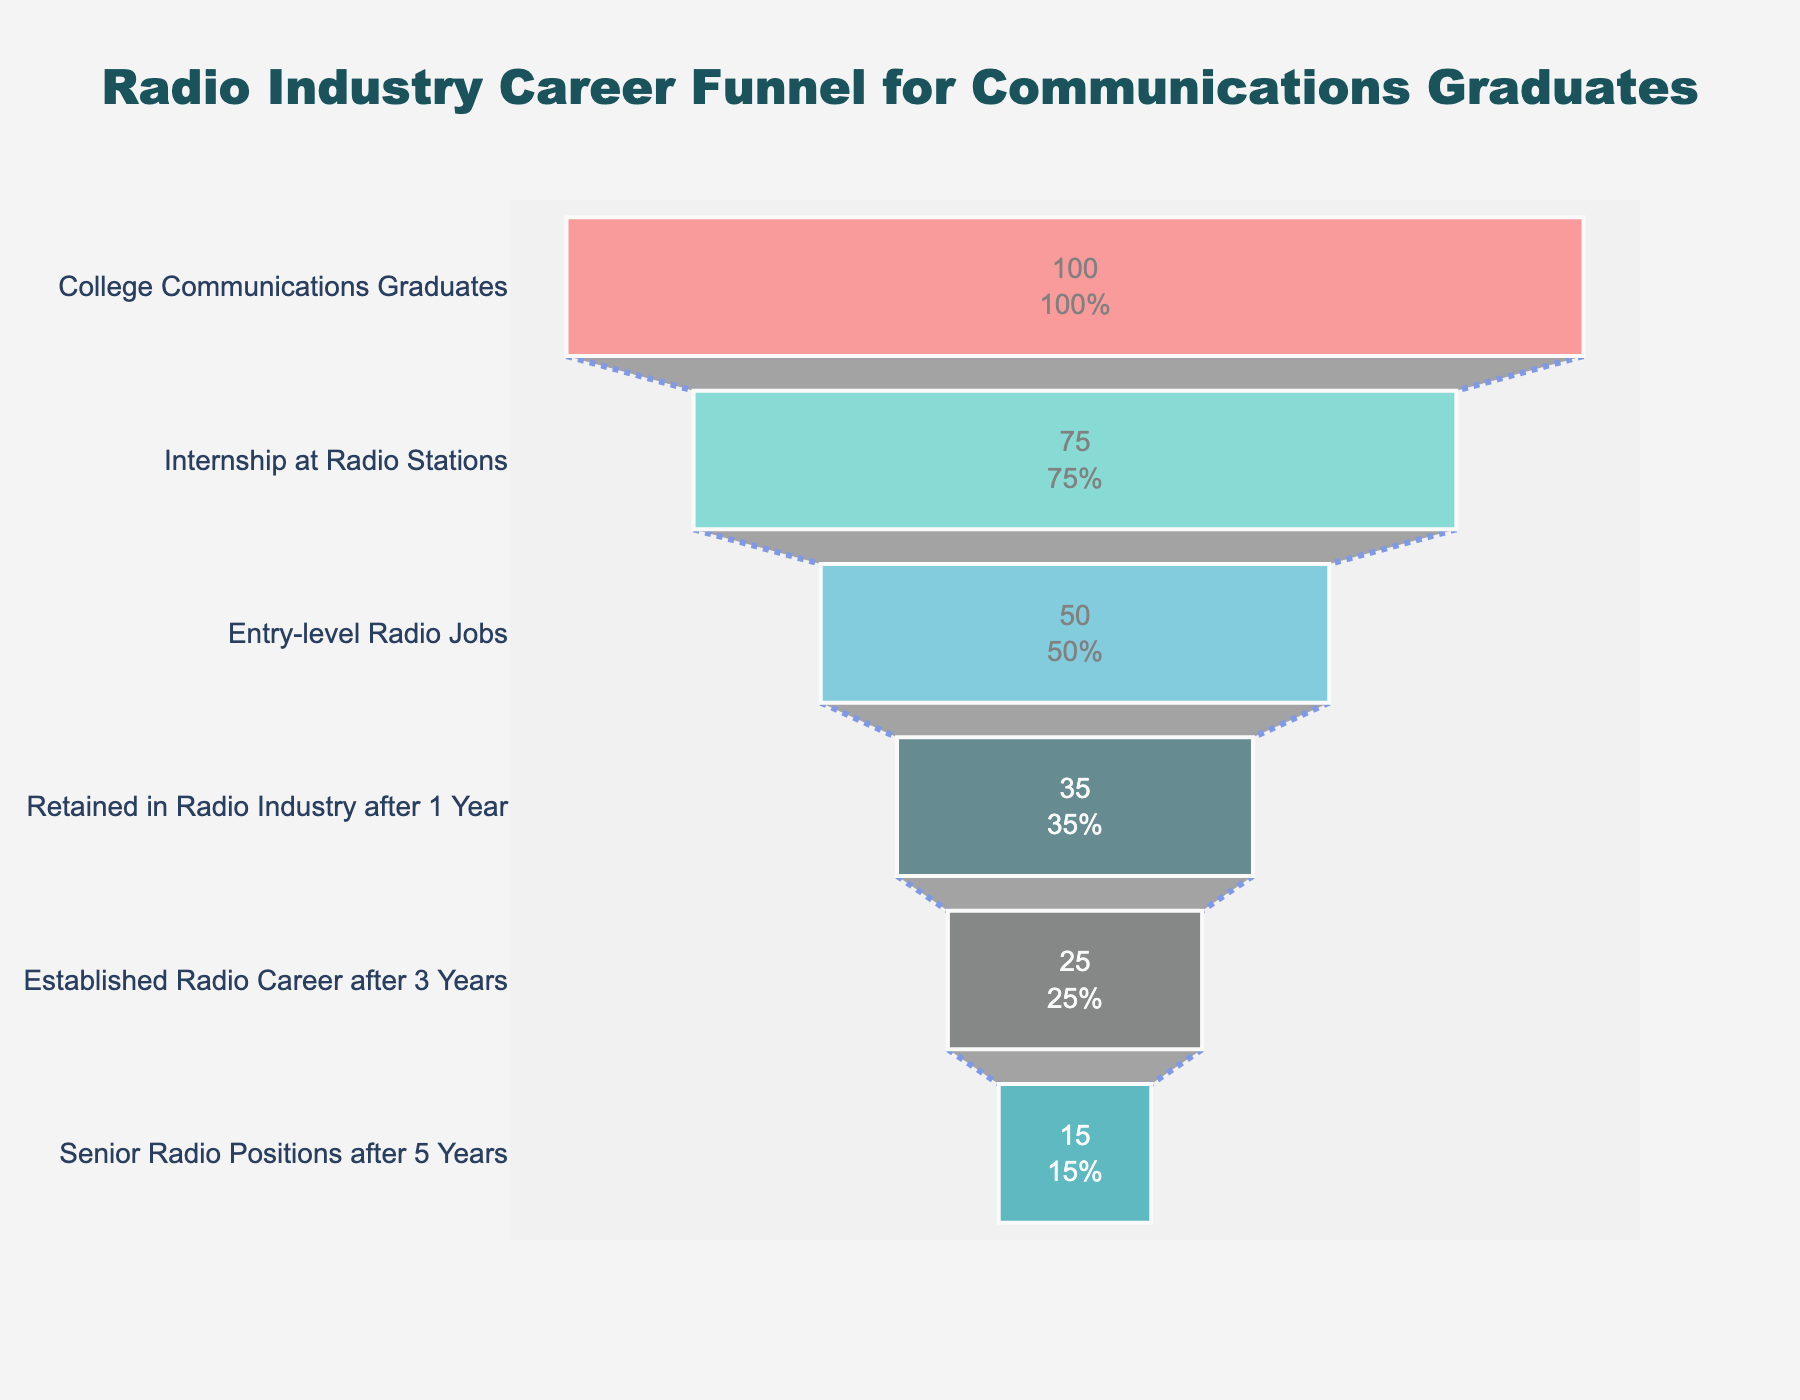What is the title of the funnel chart? The title of the funnel chart is positioned at the top center of the visual and provides an overview of what the chart represents.
Answer: "Radio Industry Career Funnel for Communications Graduates" How many stages are displayed in the funnel chart? Count the number of unique stages listed on the y-axis of the chart.
Answer: 6 What percentage of college communications graduates secure internships at radio stations? This information is displayed at the top section of the funnel chart, indicating the first conversion rate from the total number of graduates.
Answer: 75% By how many percentage points do the graduates decrease from interning at radio stations to getting entry-level radio jobs? Subtract the percentage of graduates who get entry-level radio jobs from those who get internships.
Answer: 25 percentage points Which stage has the lowest percentage of graduates? Identify the stage of the funnel chart that shows the smallest percentage value.
Answer: Senior Radio Positions after 5 Years What is the percentage of graduates who establish a radio career after 3 years? Look for the percentage value corresponding to the stage labeled "Established Radio Career after 3 Years."
Answer: 25% How does the percentage of graduates retained in the radio industry after 1 year compare to those who establish a career after 3 years? Compare the percentage values at both stages. Specifically, determine if the former is greater than the latter.
Answer: Greater (35% vs. 25%) What is the percentage drop from graduates who are retained in the radio industry after 1 year to those with senior radio positions after 5 years? Subtract the percentage of graduates in senior radio positions from those retained after 1 year.
Answer: 20 percentage points What are the marker colors associated with the funnel chart segments? Identify the colors used for the different segments, often represented as a key or visually distinguishable on the chart.
Answer: #FF6B6B, #4ECDC4, #45B7D1, #1A535C, #4A4E4D, #0E9AA7 